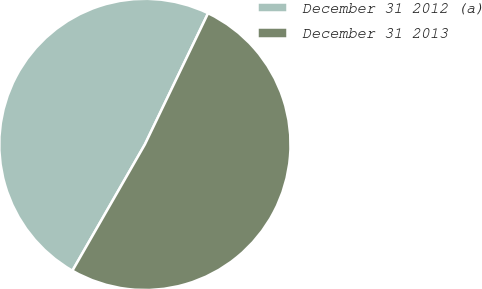<chart> <loc_0><loc_0><loc_500><loc_500><pie_chart><fcel>December 31 2012 (a)<fcel>December 31 2013<nl><fcel>48.85%<fcel>51.15%<nl></chart> 